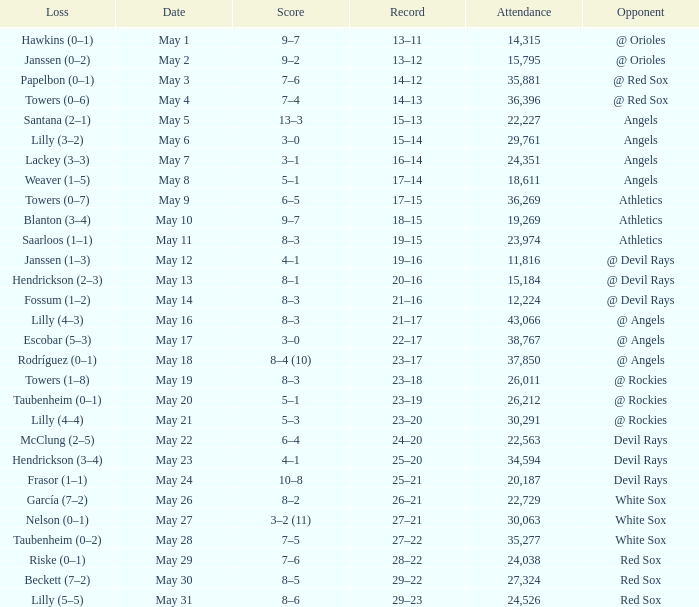When the team had their record of 16–14, what was the total attendance? 1.0. Would you be able to parse every entry in this table? {'header': ['Loss', 'Date', 'Score', 'Record', 'Attendance', 'Opponent'], 'rows': [['Hawkins (0–1)', 'May 1', '9–7', '13–11', '14,315', '@ Orioles'], ['Janssen (0–2)', 'May 2', '9–2', '13–12', '15,795', '@ Orioles'], ['Papelbon (0–1)', 'May 3', '7–6', '14–12', '35,881', '@ Red Sox'], ['Towers (0–6)', 'May 4', '7–4', '14–13', '36,396', '@ Red Sox'], ['Santana (2–1)', 'May 5', '13–3', '15–13', '22,227', 'Angels'], ['Lilly (3–2)', 'May 6', '3–0', '15–14', '29,761', 'Angels'], ['Lackey (3–3)', 'May 7', '3–1', '16–14', '24,351', 'Angels'], ['Weaver (1–5)', 'May 8', '5–1', '17–14', '18,611', 'Angels'], ['Towers (0–7)', 'May 9', '6–5', '17–15', '36,269', 'Athletics'], ['Blanton (3–4)', 'May 10', '9–7', '18–15', '19,269', 'Athletics'], ['Saarloos (1–1)', 'May 11', '8–3', '19–15', '23,974', 'Athletics'], ['Janssen (1–3)', 'May 12', '4–1', '19–16', '11,816', '@ Devil Rays'], ['Hendrickson (2–3)', 'May 13', '8–1', '20–16', '15,184', '@ Devil Rays'], ['Fossum (1–2)', 'May 14', '8–3', '21–16', '12,224', '@ Devil Rays'], ['Lilly (4–3)', 'May 16', '8–3', '21–17', '43,066', '@ Angels'], ['Escobar (5–3)', 'May 17', '3–0', '22–17', '38,767', '@ Angels'], ['Rodríguez (0–1)', 'May 18', '8–4 (10)', '23–17', '37,850', '@ Angels'], ['Towers (1–8)', 'May 19', '8–3', '23–18', '26,011', '@ Rockies'], ['Taubenheim (0–1)', 'May 20', '5–1', '23–19', '26,212', '@ Rockies'], ['Lilly (4–4)', 'May 21', '5–3', '23–20', '30,291', '@ Rockies'], ['McClung (2–5)', 'May 22', '6–4', '24–20', '22,563', 'Devil Rays'], ['Hendrickson (3–4)', 'May 23', '4–1', '25–20', '34,594', 'Devil Rays'], ['Frasor (1–1)', 'May 24', '10–8', '25–21', '20,187', 'Devil Rays'], ['García (7–2)', 'May 26', '8–2', '26–21', '22,729', 'White Sox'], ['Nelson (0–1)', 'May 27', '3–2 (11)', '27–21', '30,063', 'White Sox'], ['Taubenheim (0–2)', 'May 28', '7–5', '27–22', '35,277', 'White Sox'], ['Riske (0–1)', 'May 29', '7–6', '28–22', '24,038', 'Red Sox'], ['Beckett (7–2)', 'May 30', '8–5', '29–22', '27,324', 'Red Sox'], ['Lilly (5–5)', 'May 31', '8–6', '29–23', '24,526', 'Red Sox']]} 